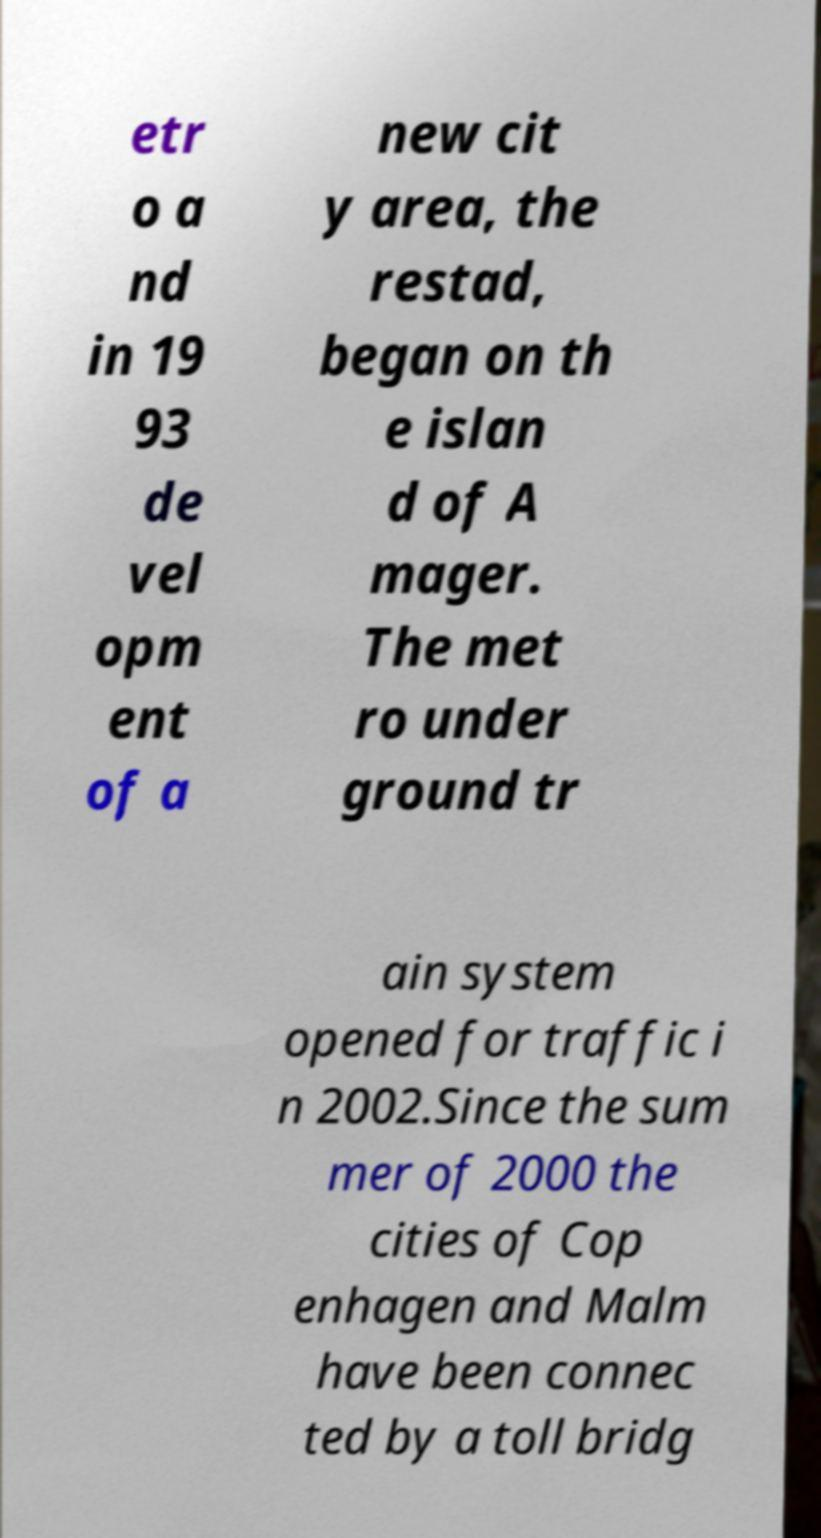Please read and relay the text visible in this image. What does it say? etr o a nd in 19 93 de vel opm ent of a new cit y area, the restad, began on th e islan d of A mager. The met ro under ground tr ain system opened for traffic i n 2002.Since the sum mer of 2000 the cities of Cop enhagen and Malm have been connec ted by a toll bridg 